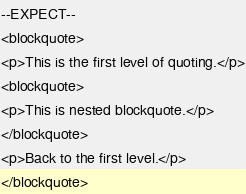<code> <loc_0><loc_0><loc_500><loc_500><_PHP_>--EXPECT--
<blockquote>
<p>This is the first level of quoting.</p>
<blockquote>
<p>This is nested blockquote.</p>
</blockquote>
<p>Back to the first level.</p>
</blockquote>
</code> 